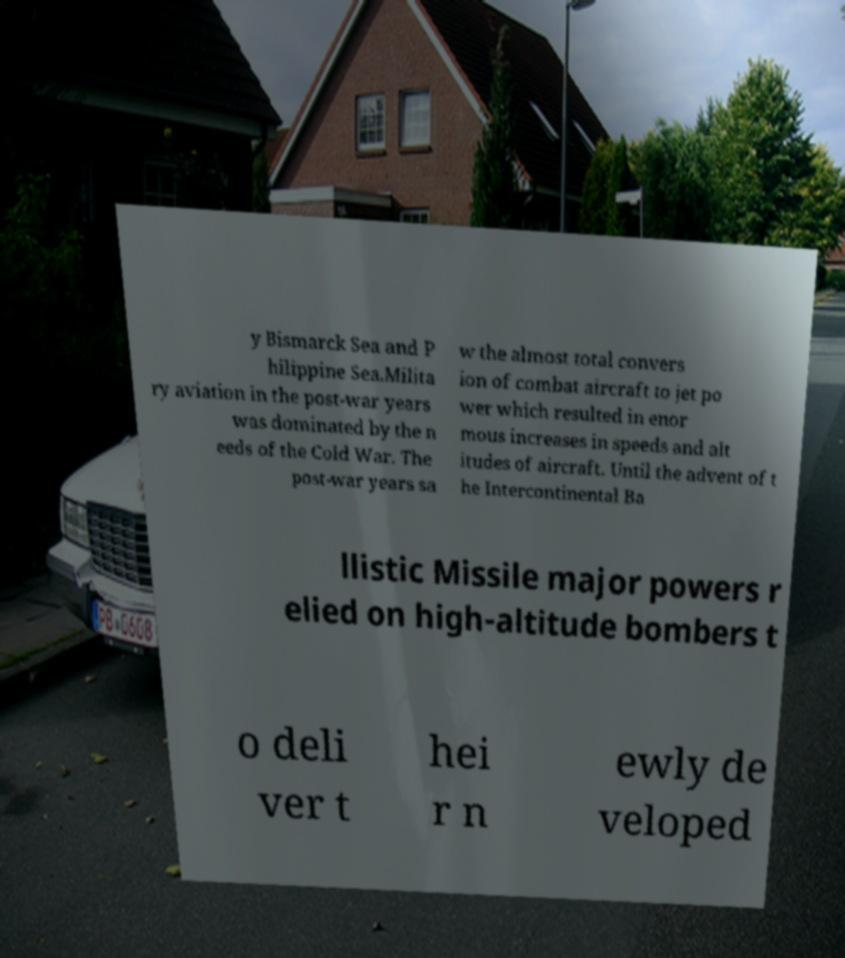Can you accurately transcribe the text from the provided image for me? y Bismarck Sea and P hilippine Sea.Milita ry aviation in the post-war years was dominated by the n eeds of the Cold War. The post-war years sa w the almost total convers ion of combat aircraft to jet po wer which resulted in enor mous increases in speeds and alt itudes of aircraft. Until the advent of t he Intercontinental Ba llistic Missile major powers r elied on high-altitude bombers t o deli ver t hei r n ewly de veloped 